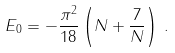Convert formula to latex. <formula><loc_0><loc_0><loc_500><loc_500>E _ { 0 } = - \frac { \pi ^ { 2 } } { 1 8 } \left ( N + \frac { 7 } { N } \right ) \, .</formula> 